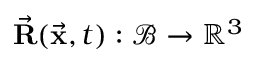Convert formula to latex. <formula><loc_0><loc_0><loc_500><loc_500>\vec { R } ( \vec { x } , t ) \colon \mathcal { B } \rightarrow \mathbb { R } ^ { 3 }</formula> 